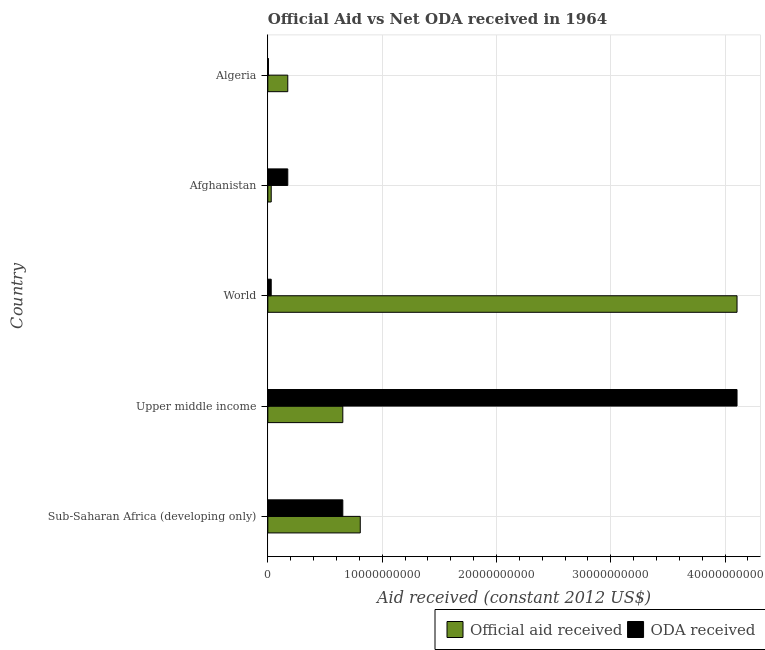Are the number of bars per tick equal to the number of legend labels?
Give a very brief answer. Yes. Are the number of bars on each tick of the Y-axis equal?
Keep it short and to the point. Yes. How many bars are there on the 5th tick from the top?
Make the answer very short. 2. What is the label of the 1st group of bars from the top?
Give a very brief answer. Algeria. What is the official aid received in Algeria?
Ensure brevity in your answer.  1.74e+09. Across all countries, what is the maximum oda received?
Ensure brevity in your answer.  4.10e+1. Across all countries, what is the minimum oda received?
Your response must be concise. 5.37e+07. In which country was the oda received maximum?
Provide a succinct answer. Upper middle income. In which country was the oda received minimum?
Ensure brevity in your answer.  Algeria. What is the total oda received in the graph?
Provide a succinct answer. 4.97e+1. What is the difference between the official aid received in Afghanistan and that in Upper middle income?
Offer a very short reply. -6.26e+09. What is the difference between the oda received in World and the official aid received in Upper middle income?
Your answer should be compact. -6.26e+09. What is the average oda received per country?
Keep it short and to the point. 9.94e+09. What is the difference between the oda received and official aid received in Afghanistan?
Ensure brevity in your answer.  1.45e+09. In how many countries, is the oda received greater than 36000000000 US$?
Provide a succinct answer. 1. What is the ratio of the oda received in Algeria to that in Upper middle income?
Your answer should be compact. 0. Is the difference between the official aid received in Sub-Saharan Africa (developing only) and World greater than the difference between the oda received in Sub-Saharan Africa (developing only) and World?
Your answer should be compact. No. What is the difference between the highest and the second highest oda received?
Keep it short and to the point. 3.45e+1. What is the difference between the highest and the lowest oda received?
Keep it short and to the point. 4.10e+1. What does the 2nd bar from the top in Sub-Saharan Africa (developing only) represents?
Keep it short and to the point. Official aid received. What does the 1st bar from the bottom in Afghanistan represents?
Offer a terse response. Official aid received. How many bars are there?
Your response must be concise. 10. Are all the bars in the graph horizontal?
Offer a terse response. Yes. What is the difference between two consecutive major ticks on the X-axis?
Your answer should be very brief. 1.00e+1. Are the values on the major ticks of X-axis written in scientific E-notation?
Provide a succinct answer. No. Does the graph contain any zero values?
Provide a succinct answer. No. How many legend labels are there?
Keep it short and to the point. 2. How are the legend labels stacked?
Give a very brief answer. Horizontal. What is the title of the graph?
Provide a succinct answer. Official Aid vs Net ODA received in 1964 . What is the label or title of the X-axis?
Your answer should be compact. Aid received (constant 2012 US$). What is the Aid received (constant 2012 US$) in Official aid received in Sub-Saharan Africa (developing only)?
Your answer should be compact. 8.09e+09. What is the Aid received (constant 2012 US$) in ODA received in Sub-Saharan Africa (developing only)?
Your response must be concise. 6.56e+09. What is the Aid received (constant 2012 US$) in Official aid received in Upper middle income?
Provide a succinct answer. 6.56e+09. What is the Aid received (constant 2012 US$) of ODA received in Upper middle income?
Give a very brief answer. 4.10e+1. What is the Aid received (constant 2012 US$) of Official aid received in World?
Your answer should be very brief. 4.10e+1. What is the Aid received (constant 2012 US$) of ODA received in World?
Keep it short and to the point. 2.95e+08. What is the Aid received (constant 2012 US$) of Official aid received in Afghanistan?
Provide a succinct answer. 2.95e+08. What is the Aid received (constant 2012 US$) in ODA received in Afghanistan?
Your answer should be compact. 1.74e+09. What is the Aid received (constant 2012 US$) in Official aid received in Algeria?
Your response must be concise. 1.74e+09. What is the Aid received (constant 2012 US$) in ODA received in Algeria?
Offer a terse response. 5.37e+07. Across all countries, what is the maximum Aid received (constant 2012 US$) in Official aid received?
Make the answer very short. 4.10e+1. Across all countries, what is the maximum Aid received (constant 2012 US$) in ODA received?
Your response must be concise. 4.10e+1. Across all countries, what is the minimum Aid received (constant 2012 US$) in Official aid received?
Make the answer very short. 2.95e+08. Across all countries, what is the minimum Aid received (constant 2012 US$) in ODA received?
Make the answer very short. 5.37e+07. What is the total Aid received (constant 2012 US$) of Official aid received in the graph?
Your answer should be compact. 5.77e+1. What is the total Aid received (constant 2012 US$) in ODA received in the graph?
Offer a terse response. 4.97e+1. What is the difference between the Aid received (constant 2012 US$) of Official aid received in Sub-Saharan Africa (developing only) and that in Upper middle income?
Provide a short and direct response. 1.53e+09. What is the difference between the Aid received (constant 2012 US$) of ODA received in Sub-Saharan Africa (developing only) and that in Upper middle income?
Provide a succinct answer. -3.45e+1. What is the difference between the Aid received (constant 2012 US$) of Official aid received in Sub-Saharan Africa (developing only) and that in World?
Provide a succinct answer. -3.30e+1. What is the difference between the Aid received (constant 2012 US$) in ODA received in Sub-Saharan Africa (developing only) and that in World?
Your response must be concise. 6.26e+09. What is the difference between the Aid received (constant 2012 US$) of Official aid received in Sub-Saharan Africa (developing only) and that in Afghanistan?
Provide a short and direct response. 7.79e+09. What is the difference between the Aid received (constant 2012 US$) in ODA received in Sub-Saharan Africa (developing only) and that in Afghanistan?
Offer a very short reply. 4.82e+09. What is the difference between the Aid received (constant 2012 US$) in Official aid received in Sub-Saharan Africa (developing only) and that in Algeria?
Your answer should be very brief. 6.34e+09. What is the difference between the Aid received (constant 2012 US$) in ODA received in Sub-Saharan Africa (developing only) and that in Algeria?
Offer a very short reply. 6.50e+09. What is the difference between the Aid received (constant 2012 US$) of Official aid received in Upper middle income and that in World?
Make the answer very short. -3.45e+1. What is the difference between the Aid received (constant 2012 US$) of ODA received in Upper middle income and that in World?
Keep it short and to the point. 4.07e+1. What is the difference between the Aid received (constant 2012 US$) of Official aid received in Upper middle income and that in Afghanistan?
Your answer should be very brief. 6.26e+09. What is the difference between the Aid received (constant 2012 US$) in ODA received in Upper middle income and that in Afghanistan?
Your response must be concise. 3.93e+1. What is the difference between the Aid received (constant 2012 US$) in Official aid received in Upper middle income and that in Algeria?
Give a very brief answer. 4.82e+09. What is the difference between the Aid received (constant 2012 US$) of ODA received in Upper middle income and that in Algeria?
Offer a terse response. 4.10e+1. What is the difference between the Aid received (constant 2012 US$) in Official aid received in World and that in Afghanistan?
Ensure brevity in your answer.  4.07e+1. What is the difference between the Aid received (constant 2012 US$) in ODA received in World and that in Afghanistan?
Your response must be concise. -1.45e+09. What is the difference between the Aid received (constant 2012 US$) of Official aid received in World and that in Algeria?
Your answer should be compact. 3.93e+1. What is the difference between the Aid received (constant 2012 US$) of ODA received in World and that in Algeria?
Provide a short and direct response. 2.41e+08. What is the difference between the Aid received (constant 2012 US$) of Official aid received in Afghanistan and that in Algeria?
Provide a succinct answer. -1.45e+09. What is the difference between the Aid received (constant 2012 US$) of ODA received in Afghanistan and that in Algeria?
Offer a terse response. 1.69e+09. What is the difference between the Aid received (constant 2012 US$) in Official aid received in Sub-Saharan Africa (developing only) and the Aid received (constant 2012 US$) in ODA received in Upper middle income?
Give a very brief answer. -3.30e+1. What is the difference between the Aid received (constant 2012 US$) in Official aid received in Sub-Saharan Africa (developing only) and the Aid received (constant 2012 US$) in ODA received in World?
Keep it short and to the point. 7.79e+09. What is the difference between the Aid received (constant 2012 US$) of Official aid received in Sub-Saharan Africa (developing only) and the Aid received (constant 2012 US$) of ODA received in Afghanistan?
Your answer should be very brief. 6.34e+09. What is the difference between the Aid received (constant 2012 US$) of Official aid received in Sub-Saharan Africa (developing only) and the Aid received (constant 2012 US$) of ODA received in Algeria?
Your answer should be compact. 8.03e+09. What is the difference between the Aid received (constant 2012 US$) in Official aid received in Upper middle income and the Aid received (constant 2012 US$) in ODA received in World?
Provide a short and direct response. 6.26e+09. What is the difference between the Aid received (constant 2012 US$) in Official aid received in Upper middle income and the Aid received (constant 2012 US$) in ODA received in Afghanistan?
Make the answer very short. 4.82e+09. What is the difference between the Aid received (constant 2012 US$) of Official aid received in Upper middle income and the Aid received (constant 2012 US$) of ODA received in Algeria?
Give a very brief answer. 6.50e+09. What is the difference between the Aid received (constant 2012 US$) of Official aid received in World and the Aid received (constant 2012 US$) of ODA received in Afghanistan?
Provide a succinct answer. 3.93e+1. What is the difference between the Aid received (constant 2012 US$) of Official aid received in World and the Aid received (constant 2012 US$) of ODA received in Algeria?
Provide a succinct answer. 4.10e+1. What is the difference between the Aid received (constant 2012 US$) of Official aid received in Afghanistan and the Aid received (constant 2012 US$) of ODA received in Algeria?
Provide a short and direct response. 2.41e+08. What is the average Aid received (constant 2012 US$) of Official aid received per country?
Ensure brevity in your answer.  1.15e+1. What is the average Aid received (constant 2012 US$) in ODA received per country?
Keep it short and to the point. 9.94e+09. What is the difference between the Aid received (constant 2012 US$) in Official aid received and Aid received (constant 2012 US$) in ODA received in Sub-Saharan Africa (developing only)?
Make the answer very short. 1.53e+09. What is the difference between the Aid received (constant 2012 US$) in Official aid received and Aid received (constant 2012 US$) in ODA received in Upper middle income?
Give a very brief answer. -3.45e+1. What is the difference between the Aid received (constant 2012 US$) of Official aid received and Aid received (constant 2012 US$) of ODA received in World?
Keep it short and to the point. 4.07e+1. What is the difference between the Aid received (constant 2012 US$) of Official aid received and Aid received (constant 2012 US$) of ODA received in Afghanistan?
Provide a short and direct response. -1.45e+09. What is the difference between the Aid received (constant 2012 US$) in Official aid received and Aid received (constant 2012 US$) in ODA received in Algeria?
Keep it short and to the point. 1.69e+09. What is the ratio of the Aid received (constant 2012 US$) in Official aid received in Sub-Saharan Africa (developing only) to that in Upper middle income?
Make the answer very short. 1.23. What is the ratio of the Aid received (constant 2012 US$) in ODA received in Sub-Saharan Africa (developing only) to that in Upper middle income?
Offer a terse response. 0.16. What is the ratio of the Aid received (constant 2012 US$) in Official aid received in Sub-Saharan Africa (developing only) to that in World?
Your answer should be very brief. 0.2. What is the ratio of the Aid received (constant 2012 US$) in ODA received in Sub-Saharan Africa (developing only) to that in World?
Offer a very short reply. 22.27. What is the ratio of the Aid received (constant 2012 US$) in Official aid received in Sub-Saharan Africa (developing only) to that in Afghanistan?
Give a very brief answer. 27.45. What is the ratio of the Aid received (constant 2012 US$) in ODA received in Sub-Saharan Africa (developing only) to that in Afghanistan?
Ensure brevity in your answer.  3.76. What is the ratio of the Aid received (constant 2012 US$) of Official aid received in Sub-Saharan Africa (developing only) to that in Algeria?
Keep it short and to the point. 4.64. What is the ratio of the Aid received (constant 2012 US$) in ODA received in Sub-Saharan Africa (developing only) to that in Algeria?
Offer a terse response. 122.2. What is the ratio of the Aid received (constant 2012 US$) of Official aid received in Upper middle income to that in World?
Offer a terse response. 0.16. What is the ratio of the Aid received (constant 2012 US$) in ODA received in Upper middle income to that in World?
Your answer should be compact. 139.36. What is the ratio of the Aid received (constant 2012 US$) of Official aid received in Upper middle income to that in Afghanistan?
Make the answer very short. 22.27. What is the ratio of the Aid received (constant 2012 US$) of ODA received in Upper middle income to that in Afghanistan?
Your answer should be compact. 23.54. What is the ratio of the Aid received (constant 2012 US$) in Official aid received in Upper middle income to that in Algeria?
Your response must be concise. 3.76. What is the ratio of the Aid received (constant 2012 US$) of ODA received in Upper middle income to that in Algeria?
Give a very brief answer. 764.74. What is the ratio of the Aid received (constant 2012 US$) of Official aid received in World to that in Afghanistan?
Ensure brevity in your answer.  139.36. What is the ratio of the Aid received (constant 2012 US$) of ODA received in World to that in Afghanistan?
Provide a short and direct response. 0.17. What is the ratio of the Aid received (constant 2012 US$) of Official aid received in World to that in Algeria?
Keep it short and to the point. 23.54. What is the ratio of the Aid received (constant 2012 US$) in ODA received in World to that in Algeria?
Offer a very short reply. 5.49. What is the ratio of the Aid received (constant 2012 US$) in Official aid received in Afghanistan to that in Algeria?
Keep it short and to the point. 0.17. What is the ratio of the Aid received (constant 2012 US$) of ODA received in Afghanistan to that in Algeria?
Offer a very short reply. 32.48. What is the difference between the highest and the second highest Aid received (constant 2012 US$) of Official aid received?
Give a very brief answer. 3.30e+1. What is the difference between the highest and the second highest Aid received (constant 2012 US$) in ODA received?
Offer a very short reply. 3.45e+1. What is the difference between the highest and the lowest Aid received (constant 2012 US$) in Official aid received?
Your answer should be compact. 4.07e+1. What is the difference between the highest and the lowest Aid received (constant 2012 US$) of ODA received?
Offer a terse response. 4.10e+1. 